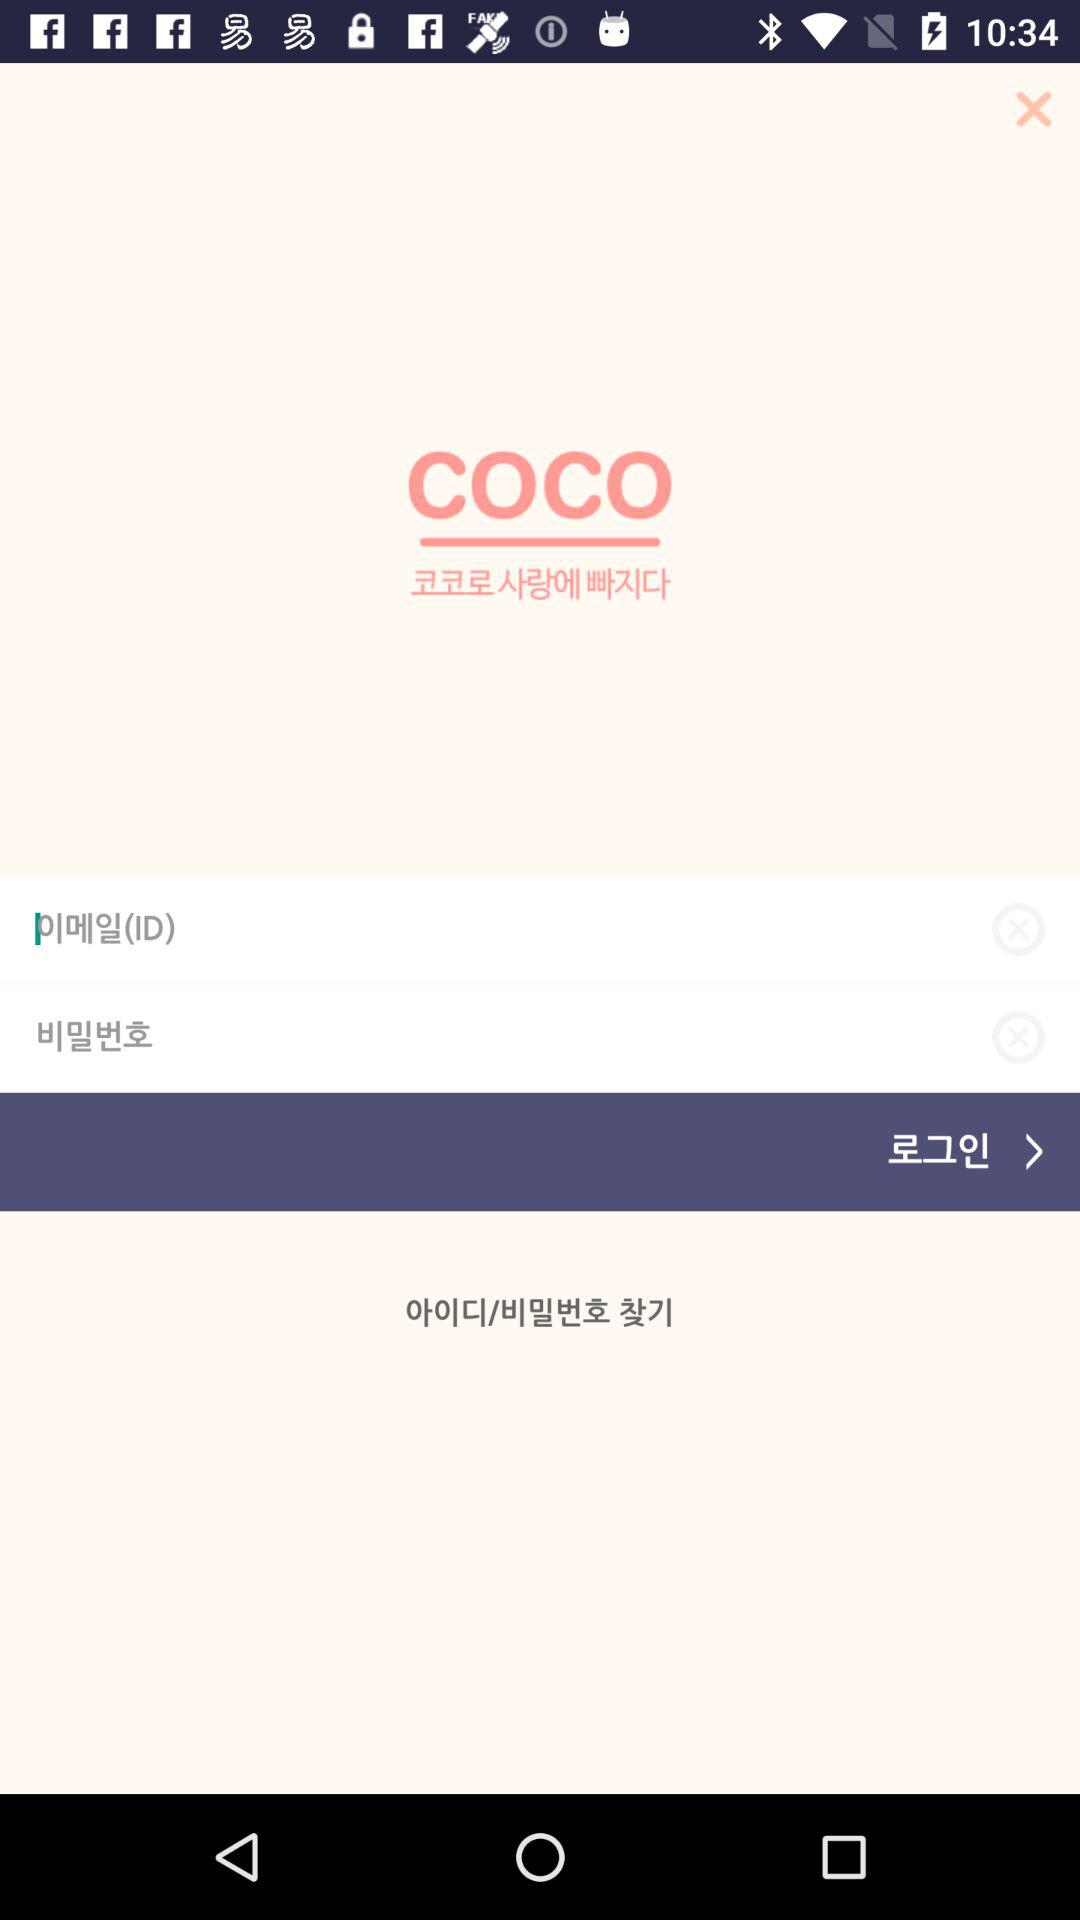How many input fields are there for the login screen?
Answer the question using a single word or phrase. 2 